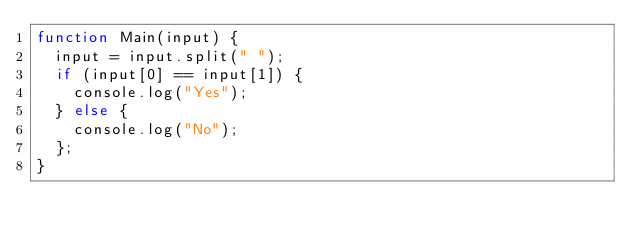<code> <loc_0><loc_0><loc_500><loc_500><_JavaScript_>function Main(input) {
  input = input.split(" ");
  if (input[0] == input[1]) {
    console.log("Yes");
  } else {
    console.log("No");
  };
}</code> 